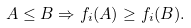Convert formula to latex. <formula><loc_0><loc_0><loc_500><loc_500>A \leq B \Rightarrow f _ { i } ( A ) \geq f _ { i } ( B ) .</formula> 